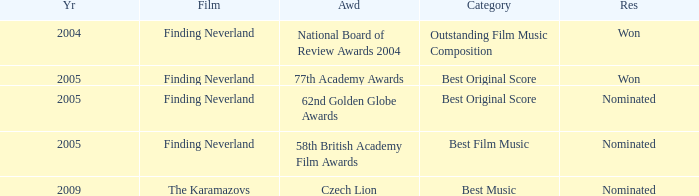What were the findings for years preceding 2005? Won. 